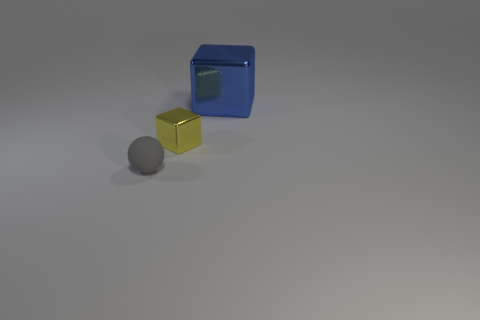Add 2 big cubes. How many objects exist? 5 Subtract all spheres. How many objects are left? 2 Add 1 tiny blocks. How many tiny blocks are left? 2 Add 3 green rubber cubes. How many green rubber cubes exist? 3 Subtract 0 purple blocks. How many objects are left? 3 Subtract all large metal cubes. Subtract all blue metal blocks. How many objects are left? 1 